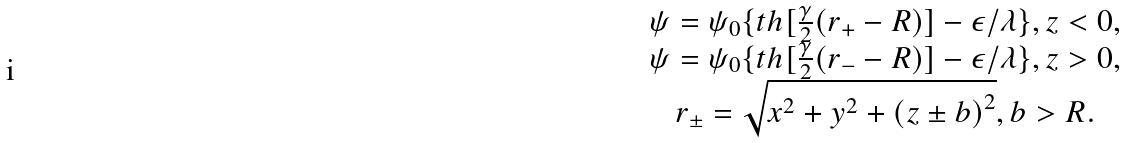Convert formula to latex. <formula><loc_0><loc_0><loc_500><loc_500>\begin{array} { c } \psi = \psi _ { 0 } \{ t h [ \frac { \gamma } { 2 } ( r _ { + } - R ) ] - \epsilon / \lambda \} , z < 0 , \\ \psi = \psi _ { 0 } \{ t h [ \frac { \gamma } { 2 } ( r _ { - } - R ) ] - \epsilon / \lambda \} , z > 0 , \\ r _ { \pm } = \sqrt { x ^ { 2 } + y ^ { 2 } + \left ( z \pm b \right ) ^ { 2 } } , b > R . \end{array}</formula> 